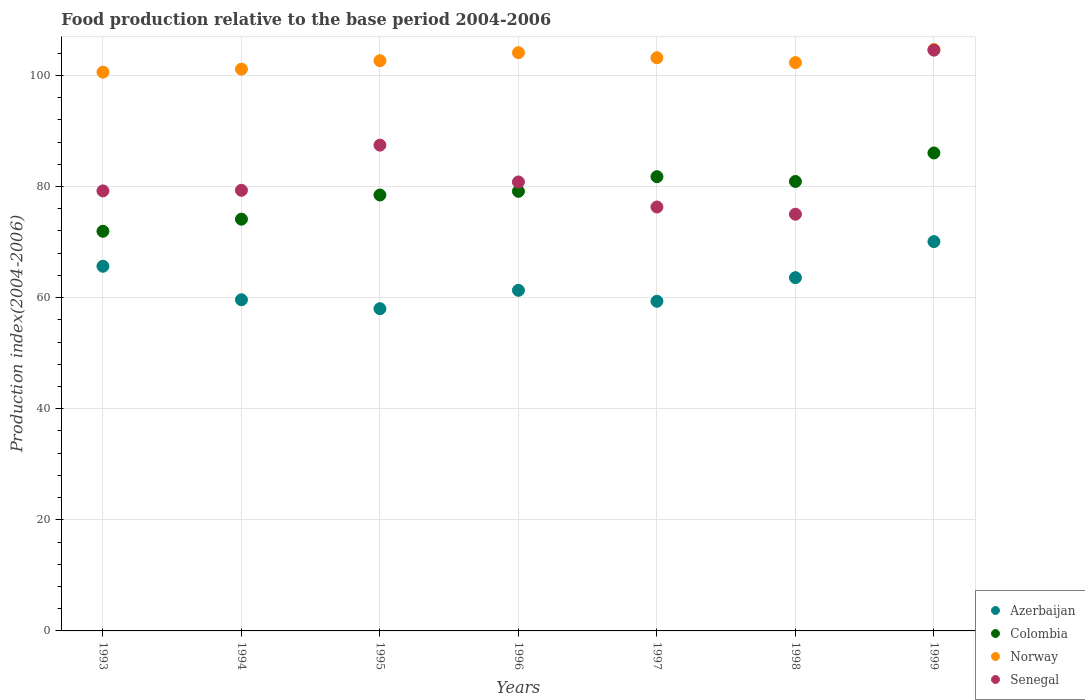How many different coloured dotlines are there?
Ensure brevity in your answer.  4. What is the food production index in Senegal in 1994?
Offer a terse response. 79.33. Across all years, what is the maximum food production index in Azerbaijan?
Your answer should be very brief. 70.09. Across all years, what is the minimum food production index in Colombia?
Your answer should be compact. 71.95. In which year was the food production index in Colombia maximum?
Ensure brevity in your answer.  1999. In which year was the food production index in Colombia minimum?
Offer a terse response. 1993. What is the total food production index in Senegal in the graph?
Give a very brief answer. 582.74. What is the difference between the food production index in Norway in 1996 and that in 1997?
Offer a terse response. 0.91. What is the difference between the food production index in Azerbaijan in 1994 and the food production index in Norway in 1999?
Offer a very short reply. -45.05. What is the average food production index in Senegal per year?
Keep it short and to the point. 83.25. In the year 1995, what is the difference between the food production index in Azerbaijan and food production index in Senegal?
Your answer should be compact. -29.45. What is the ratio of the food production index in Norway in 1993 to that in 1997?
Ensure brevity in your answer.  0.97. Is the food production index in Norway in 1994 less than that in 1999?
Your answer should be very brief. Yes. Is the difference between the food production index in Azerbaijan in 1995 and 1998 greater than the difference between the food production index in Senegal in 1995 and 1998?
Keep it short and to the point. No. What is the difference between the highest and the second highest food production index in Azerbaijan?
Your answer should be compact. 4.44. What is the difference between the highest and the lowest food production index in Senegal?
Your answer should be compact. 29.54. In how many years, is the food production index in Colombia greater than the average food production index in Colombia taken over all years?
Your response must be concise. 4. Is the sum of the food production index in Azerbaijan in 1996 and 1998 greater than the maximum food production index in Colombia across all years?
Provide a succinct answer. Yes. Is it the case that in every year, the sum of the food production index in Azerbaijan and food production index in Colombia  is greater than the food production index in Senegal?
Offer a very short reply. Yes. Is the food production index in Colombia strictly less than the food production index in Norway over the years?
Provide a short and direct response. Yes. How many dotlines are there?
Make the answer very short. 4. Are the values on the major ticks of Y-axis written in scientific E-notation?
Ensure brevity in your answer.  No. Does the graph contain any zero values?
Your answer should be compact. No. Does the graph contain grids?
Provide a succinct answer. Yes. Where does the legend appear in the graph?
Provide a short and direct response. Bottom right. How many legend labels are there?
Ensure brevity in your answer.  4. What is the title of the graph?
Ensure brevity in your answer.  Food production relative to the base period 2004-2006. Does "El Salvador" appear as one of the legend labels in the graph?
Provide a succinct answer. No. What is the label or title of the Y-axis?
Your response must be concise. Production index(2004-2006). What is the Production index(2004-2006) of Azerbaijan in 1993?
Make the answer very short. 65.65. What is the Production index(2004-2006) in Colombia in 1993?
Your answer should be very brief. 71.95. What is the Production index(2004-2006) of Norway in 1993?
Keep it short and to the point. 100.6. What is the Production index(2004-2006) of Senegal in 1993?
Offer a terse response. 79.22. What is the Production index(2004-2006) in Azerbaijan in 1994?
Your answer should be compact. 59.62. What is the Production index(2004-2006) of Colombia in 1994?
Keep it short and to the point. 74.13. What is the Production index(2004-2006) of Norway in 1994?
Your answer should be compact. 101.14. What is the Production index(2004-2006) of Senegal in 1994?
Make the answer very short. 79.33. What is the Production index(2004-2006) in Azerbaijan in 1995?
Your answer should be compact. 58.01. What is the Production index(2004-2006) of Colombia in 1995?
Provide a succinct answer. 78.48. What is the Production index(2004-2006) of Norway in 1995?
Offer a terse response. 102.66. What is the Production index(2004-2006) in Senegal in 1995?
Keep it short and to the point. 87.46. What is the Production index(2004-2006) of Azerbaijan in 1996?
Ensure brevity in your answer.  61.32. What is the Production index(2004-2006) in Colombia in 1996?
Ensure brevity in your answer.  79.14. What is the Production index(2004-2006) of Norway in 1996?
Offer a very short reply. 104.1. What is the Production index(2004-2006) in Senegal in 1996?
Offer a terse response. 80.83. What is the Production index(2004-2006) of Azerbaijan in 1997?
Your response must be concise. 59.35. What is the Production index(2004-2006) in Colombia in 1997?
Your answer should be compact. 81.78. What is the Production index(2004-2006) of Norway in 1997?
Make the answer very short. 103.19. What is the Production index(2004-2006) of Senegal in 1997?
Ensure brevity in your answer.  76.32. What is the Production index(2004-2006) of Azerbaijan in 1998?
Provide a short and direct response. 63.6. What is the Production index(2004-2006) of Colombia in 1998?
Provide a succinct answer. 80.92. What is the Production index(2004-2006) in Norway in 1998?
Your answer should be very brief. 102.32. What is the Production index(2004-2006) in Senegal in 1998?
Provide a short and direct response. 75.02. What is the Production index(2004-2006) in Azerbaijan in 1999?
Ensure brevity in your answer.  70.09. What is the Production index(2004-2006) of Colombia in 1999?
Offer a terse response. 86.05. What is the Production index(2004-2006) in Norway in 1999?
Give a very brief answer. 104.67. What is the Production index(2004-2006) of Senegal in 1999?
Your answer should be compact. 104.56. Across all years, what is the maximum Production index(2004-2006) in Azerbaijan?
Offer a very short reply. 70.09. Across all years, what is the maximum Production index(2004-2006) of Colombia?
Offer a very short reply. 86.05. Across all years, what is the maximum Production index(2004-2006) in Norway?
Offer a terse response. 104.67. Across all years, what is the maximum Production index(2004-2006) of Senegal?
Offer a very short reply. 104.56. Across all years, what is the minimum Production index(2004-2006) in Azerbaijan?
Make the answer very short. 58.01. Across all years, what is the minimum Production index(2004-2006) in Colombia?
Your answer should be very brief. 71.95. Across all years, what is the minimum Production index(2004-2006) of Norway?
Your response must be concise. 100.6. Across all years, what is the minimum Production index(2004-2006) in Senegal?
Offer a terse response. 75.02. What is the total Production index(2004-2006) of Azerbaijan in the graph?
Your answer should be very brief. 437.64. What is the total Production index(2004-2006) of Colombia in the graph?
Your answer should be compact. 552.45. What is the total Production index(2004-2006) of Norway in the graph?
Your answer should be compact. 718.68. What is the total Production index(2004-2006) of Senegal in the graph?
Make the answer very short. 582.74. What is the difference between the Production index(2004-2006) in Azerbaijan in 1993 and that in 1994?
Your answer should be compact. 6.03. What is the difference between the Production index(2004-2006) of Colombia in 1993 and that in 1994?
Keep it short and to the point. -2.18. What is the difference between the Production index(2004-2006) in Norway in 1993 and that in 1994?
Provide a succinct answer. -0.54. What is the difference between the Production index(2004-2006) in Senegal in 1993 and that in 1994?
Your answer should be very brief. -0.11. What is the difference between the Production index(2004-2006) of Azerbaijan in 1993 and that in 1995?
Offer a very short reply. 7.64. What is the difference between the Production index(2004-2006) in Colombia in 1993 and that in 1995?
Keep it short and to the point. -6.53. What is the difference between the Production index(2004-2006) of Norway in 1993 and that in 1995?
Your answer should be very brief. -2.06. What is the difference between the Production index(2004-2006) in Senegal in 1993 and that in 1995?
Offer a very short reply. -8.24. What is the difference between the Production index(2004-2006) of Azerbaijan in 1993 and that in 1996?
Provide a short and direct response. 4.33. What is the difference between the Production index(2004-2006) in Colombia in 1993 and that in 1996?
Your answer should be compact. -7.19. What is the difference between the Production index(2004-2006) of Senegal in 1993 and that in 1996?
Your answer should be very brief. -1.61. What is the difference between the Production index(2004-2006) in Azerbaijan in 1993 and that in 1997?
Your answer should be very brief. 6.3. What is the difference between the Production index(2004-2006) of Colombia in 1993 and that in 1997?
Your answer should be compact. -9.83. What is the difference between the Production index(2004-2006) in Norway in 1993 and that in 1997?
Offer a terse response. -2.59. What is the difference between the Production index(2004-2006) of Azerbaijan in 1993 and that in 1998?
Your answer should be compact. 2.05. What is the difference between the Production index(2004-2006) in Colombia in 1993 and that in 1998?
Provide a succinct answer. -8.97. What is the difference between the Production index(2004-2006) in Norway in 1993 and that in 1998?
Provide a short and direct response. -1.72. What is the difference between the Production index(2004-2006) of Senegal in 1993 and that in 1998?
Give a very brief answer. 4.2. What is the difference between the Production index(2004-2006) in Azerbaijan in 1993 and that in 1999?
Offer a very short reply. -4.44. What is the difference between the Production index(2004-2006) of Colombia in 1993 and that in 1999?
Provide a succinct answer. -14.1. What is the difference between the Production index(2004-2006) of Norway in 1993 and that in 1999?
Your answer should be very brief. -4.07. What is the difference between the Production index(2004-2006) of Senegal in 1993 and that in 1999?
Your response must be concise. -25.34. What is the difference between the Production index(2004-2006) in Azerbaijan in 1994 and that in 1995?
Provide a short and direct response. 1.61. What is the difference between the Production index(2004-2006) of Colombia in 1994 and that in 1995?
Give a very brief answer. -4.35. What is the difference between the Production index(2004-2006) of Norway in 1994 and that in 1995?
Your answer should be very brief. -1.52. What is the difference between the Production index(2004-2006) in Senegal in 1994 and that in 1995?
Your response must be concise. -8.13. What is the difference between the Production index(2004-2006) in Colombia in 1994 and that in 1996?
Your answer should be compact. -5.01. What is the difference between the Production index(2004-2006) of Norway in 1994 and that in 1996?
Provide a short and direct response. -2.96. What is the difference between the Production index(2004-2006) in Senegal in 1994 and that in 1996?
Provide a short and direct response. -1.5. What is the difference between the Production index(2004-2006) in Azerbaijan in 1994 and that in 1997?
Provide a succinct answer. 0.27. What is the difference between the Production index(2004-2006) in Colombia in 1994 and that in 1997?
Provide a short and direct response. -7.65. What is the difference between the Production index(2004-2006) in Norway in 1994 and that in 1997?
Offer a terse response. -2.05. What is the difference between the Production index(2004-2006) of Senegal in 1994 and that in 1997?
Ensure brevity in your answer.  3.01. What is the difference between the Production index(2004-2006) of Azerbaijan in 1994 and that in 1998?
Provide a short and direct response. -3.98. What is the difference between the Production index(2004-2006) of Colombia in 1994 and that in 1998?
Your answer should be very brief. -6.79. What is the difference between the Production index(2004-2006) in Norway in 1994 and that in 1998?
Keep it short and to the point. -1.18. What is the difference between the Production index(2004-2006) in Senegal in 1994 and that in 1998?
Provide a succinct answer. 4.31. What is the difference between the Production index(2004-2006) in Azerbaijan in 1994 and that in 1999?
Your answer should be compact. -10.47. What is the difference between the Production index(2004-2006) of Colombia in 1994 and that in 1999?
Make the answer very short. -11.92. What is the difference between the Production index(2004-2006) in Norway in 1994 and that in 1999?
Provide a short and direct response. -3.53. What is the difference between the Production index(2004-2006) of Senegal in 1994 and that in 1999?
Provide a short and direct response. -25.23. What is the difference between the Production index(2004-2006) in Azerbaijan in 1995 and that in 1996?
Your answer should be very brief. -3.31. What is the difference between the Production index(2004-2006) of Colombia in 1995 and that in 1996?
Give a very brief answer. -0.66. What is the difference between the Production index(2004-2006) in Norway in 1995 and that in 1996?
Make the answer very short. -1.44. What is the difference between the Production index(2004-2006) in Senegal in 1995 and that in 1996?
Your answer should be compact. 6.63. What is the difference between the Production index(2004-2006) of Azerbaijan in 1995 and that in 1997?
Provide a short and direct response. -1.34. What is the difference between the Production index(2004-2006) in Norway in 1995 and that in 1997?
Your answer should be compact. -0.53. What is the difference between the Production index(2004-2006) of Senegal in 1995 and that in 1997?
Your response must be concise. 11.14. What is the difference between the Production index(2004-2006) in Azerbaijan in 1995 and that in 1998?
Give a very brief answer. -5.59. What is the difference between the Production index(2004-2006) of Colombia in 1995 and that in 1998?
Provide a succinct answer. -2.44. What is the difference between the Production index(2004-2006) of Norway in 1995 and that in 1998?
Your answer should be very brief. 0.34. What is the difference between the Production index(2004-2006) in Senegal in 1995 and that in 1998?
Your response must be concise. 12.44. What is the difference between the Production index(2004-2006) of Azerbaijan in 1995 and that in 1999?
Make the answer very short. -12.08. What is the difference between the Production index(2004-2006) of Colombia in 1995 and that in 1999?
Give a very brief answer. -7.57. What is the difference between the Production index(2004-2006) of Norway in 1995 and that in 1999?
Offer a terse response. -2.01. What is the difference between the Production index(2004-2006) of Senegal in 1995 and that in 1999?
Provide a short and direct response. -17.1. What is the difference between the Production index(2004-2006) of Azerbaijan in 1996 and that in 1997?
Keep it short and to the point. 1.97. What is the difference between the Production index(2004-2006) in Colombia in 1996 and that in 1997?
Offer a very short reply. -2.64. What is the difference between the Production index(2004-2006) in Norway in 1996 and that in 1997?
Make the answer very short. 0.91. What is the difference between the Production index(2004-2006) in Senegal in 1996 and that in 1997?
Make the answer very short. 4.51. What is the difference between the Production index(2004-2006) in Azerbaijan in 1996 and that in 1998?
Offer a very short reply. -2.28. What is the difference between the Production index(2004-2006) in Colombia in 1996 and that in 1998?
Your answer should be very brief. -1.78. What is the difference between the Production index(2004-2006) in Norway in 1996 and that in 1998?
Your answer should be compact. 1.78. What is the difference between the Production index(2004-2006) in Senegal in 1996 and that in 1998?
Provide a short and direct response. 5.81. What is the difference between the Production index(2004-2006) of Azerbaijan in 1996 and that in 1999?
Offer a terse response. -8.77. What is the difference between the Production index(2004-2006) in Colombia in 1996 and that in 1999?
Give a very brief answer. -6.91. What is the difference between the Production index(2004-2006) of Norway in 1996 and that in 1999?
Provide a short and direct response. -0.57. What is the difference between the Production index(2004-2006) in Senegal in 1996 and that in 1999?
Offer a very short reply. -23.73. What is the difference between the Production index(2004-2006) of Azerbaijan in 1997 and that in 1998?
Provide a short and direct response. -4.25. What is the difference between the Production index(2004-2006) of Colombia in 1997 and that in 1998?
Provide a short and direct response. 0.86. What is the difference between the Production index(2004-2006) in Norway in 1997 and that in 1998?
Provide a succinct answer. 0.87. What is the difference between the Production index(2004-2006) in Azerbaijan in 1997 and that in 1999?
Offer a very short reply. -10.74. What is the difference between the Production index(2004-2006) in Colombia in 1997 and that in 1999?
Your answer should be compact. -4.27. What is the difference between the Production index(2004-2006) in Norway in 1997 and that in 1999?
Your answer should be very brief. -1.48. What is the difference between the Production index(2004-2006) of Senegal in 1997 and that in 1999?
Provide a short and direct response. -28.24. What is the difference between the Production index(2004-2006) of Azerbaijan in 1998 and that in 1999?
Your response must be concise. -6.49. What is the difference between the Production index(2004-2006) of Colombia in 1998 and that in 1999?
Provide a short and direct response. -5.13. What is the difference between the Production index(2004-2006) of Norway in 1998 and that in 1999?
Provide a short and direct response. -2.35. What is the difference between the Production index(2004-2006) of Senegal in 1998 and that in 1999?
Give a very brief answer. -29.54. What is the difference between the Production index(2004-2006) in Azerbaijan in 1993 and the Production index(2004-2006) in Colombia in 1994?
Your response must be concise. -8.48. What is the difference between the Production index(2004-2006) in Azerbaijan in 1993 and the Production index(2004-2006) in Norway in 1994?
Your response must be concise. -35.49. What is the difference between the Production index(2004-2006) of Azerbaijan in 1993 and the Production index(2004-2006) of Senegal in 1994?
Ensure brevity in your answer.  -13.68. What is the difference between the Production index(2004-2006) in Colombia in 1993 and the Production index(2004-2006) in Norway in 1994?
Provide a succinct answer. -29.19. What is the difference between the Production index(2004-2006) in Colombia in 1993 and the Production index(2004-2006) in Senegal in 1994?
Offer a terse response. -7.38. What is the difference between the Production index(2004-2006) of Norway in 1993 and the Production index(2004-2006) of Senegal in 1994?
Keep it short and to the point. 21.27. What is the difference between the Production index(2004-2006) in Azerbaijan in 1993 and the Production index(2004-2006) in Colombia in 1995?
Provide a short and direct response. -12.83. What is the difference between the Production index(2004-2006) of Azerbaijan in 1993 and the Production index(2004-2006) of Norway in 1995?
Ensure brevity in your answer.  -37.01. What is the difference between the Production index(2004-2006) of Azerbaijan in 1993 and the Production index(2004-2006) of Senegal in 1995?
Provide a short and direct response. -21.81. What is the difference between the Production index(2004-2006) of Colombia in 1993 and the Production index(2004-2006) of Norway in 1995?
Provide a succinct answer. -30.71. What is the difference between the Production index(2004-2006) of Colombia in 1993 and the Production index(2004-2006) of Senegal in 1995?
Keep it short and to the point. -15.51. What is the difference between the Production index(2004-2006) in Norway in 1993 and the Production index(2004-2006) in Senegal in 1995?
Provide a succinct answer. 13.14. What is the difference between the Production index(2004-2006) in Azerbaijan in 1993 and the Production index(2004-2006) in Colombia in 1996?
Make the answer very short. -13.49. What is the difference between the Production index(2004-2006) of Azerbaijan in 1993 and the Production index(2004-2006) of Norway in 1996?
Your answer should be very brief. -38.45. What is the difference between the Production index(2004-2006) in Azerbaijan in 1993 and the Production index(2004-2006) in Senegal in 1996?
Provide a succinct answer. -15.18. What is the difference between the Production index(2004-2006) of Colombia in 1993 and the Production index(2004-2006) of Norway in 1996?
Offer a terse response. -32.15. What is the difference between the Production index(2004-2006) in Colombia in 1993 and the Production index(2004-2006) in Senegal in 1996?
Ensure brevity in your answer.  -8.88. What is the difference between the Production index(2004-2006) of Norway in 1993 and the Production index(2004-2006) of Senegal in 1996?
Offer a very short reply. 19.77. What is the difference between the Production index(2004-2006) in Azerbaijan in 1993 and the Production index(2004-2006) in Colombia in 1997?
Your answer should be very brief. -16.13. What is the difference between the Production index(2004-2006) of Azerbaijan in 1993 and the Production index(2004-2006) of Norway in 1997?
Ensure brevity in your answer.  -37.54. What is the difference between the Production index(2004-2006) of Azerbaijan in 1993 and the Production index(2004-2006) of Senegal in 1997?
Ensure brevity in your answer.  -10.67. What is the difference between the Production index(2004-2006) of Colombia in 1993 and the Production index(2004-2006) of Norway in 1997?
Provide a short and direct response. -31.24. What is the difference between the Production index(2004-2006) of Colombia in 1993 and the Production index(2004-2006) of Senegal in 1997?
Your answer should be very brief. -4.37. What is the difference between the Production index(2004-2006) in Norway in 1993 and the Production index(2004-2006) in Senegal in 1997?
Provide a short and direct response. 24.28. What is the difference between the Production index(2004-2006) in Azerbaijan in 1993 and the Production index(2004-2006) in Colombia in 1998?
Offer a very short reply. -15.27. What is the difference between the Production index(2004-2006) in Azerbaijan in 1993 and the Production index(2004-2006) in Norway in 1998?
Give a very brief answer. -36.67. What is the difference between the Production index(2004-2006) in Azerbaijan in 1993 and the Production index(2004-2006) in Senegal in 1998?
Keep it short and to the point. -9.37. What is the difference between the Production index(2004-2006) of Colombia in 1993 and the Production index(2004-2006) of Norway in 1998?
Provide a succinct answer. -30.37. What is the difference between the Production index(2004-2006) in Colombia in 1993 and the Production index(2004-2006) in Senegal in 1998?
Make the answer very short. -3.07. What is the difference between the Production index(2004-2006) in Norway in 1993 and the Production index(2004-2006) in Senegal in 1998?
Your answer should be compact. 25.58. What is the difference between the Production index(2004-2006) of Azerbaijan in 1993 and the Production index(2004-2006) of Colombia in 1999?
Your response must be concise. -20.4. What is the difference between the Production index(2004-2006) of Azerbaijan in 1993 and the Production index(2004-2006) of Norway in 1999?
Your answer should be compact. -39.02. What is the difference between the Production index(2004-2006) in Azerbaijan in 1993 and the Production index(2004-2006) in Senegal in 1999?
Ensure brevity in your answer.  -38.91. What is the difference between the Production index(2004-2006) of Colombia in 1993 and the Production index(2004-2006) of Norway in 1999?
Make the answer very short. -32.72. What is the difference between the Production index(2004-2006) in Colombia in 1993 and the Production index(2004-2006) in Senegal in 1999?
Your response must be concise. -32.61. What is the difference between the Production index(2004-2006) in Norway in 1993 and the Production index(2004-2006) in Senegal in 1999?
Ensure brevity in your answer.  -3.96. What is the difference between the Production index(2004-2006) in Azerbaijan in 1994 and the Production index(2004-2006) in Colombia in 1995?
Your answer should be compact. -18.86. What is the difference between the Production index(2004-2006) of Azerbaijan in 1994 and the Production index(2004-2006) of Norway in 1995?
Your answer should be very brief. -43.04. What is the difference between the Production index(2004-2006) in Azerbaijan in 1994 and the Production index(2004-2006) in Senegal in 1995?
Provide a succinct answer. -27.84. What is the difference between the Production index(2004-2006) in Colombia in 1994 and the Production index(2004-2006) in Norway in 1995?
Offer a terse response. -28.53. What is the difference between the Production index(2004-2006) of Colombia in 1994 and the Production index(2004-2006) of Senegal in 1995?
Give a very brief answer. -13.33. What is the difference between the Production index(2004-2006) in Norway in 1994 and the Production index(2004-2006) in Senegal in 1995?
Give a very brief answer. 13.68. What is the difference between the Production index(2004-2006) in Azerbaijan in 1994 and the Production index(2004-2006) in Colombia in 1996?
Provide a short and direct response. -19.52. What is the difference between the Production index(2004-2006) of Azerbaijan in 1994 and the Production index(2004-2006) of Norway in 1996?
Make the answer very short. -44.48. What is the difference between the Production index(2004-2006) of Azerbaijan in 1994 and the Production index(2004-2006) of Senegal in 1996?
Provide a short and direct response. -21.21. What is the difference between the Production index(2004-2006) of Colombia in 1994 and the Production index(2004-2006) of Norway in 1996?
Ensure brevity in your answer.  -29.97. What is the difference between the Production index(2004-2006) of Norway in 1994 and the Production index(2004-2006) of Senegal in 1996?
Make the answer very short. 20.31. What is the difference between the Production index(2004-2006) of Azerbaijan in 1994 and the Production index(2004-2006) of Colombia in 1997?
Provide a short and direct response. -22.16. What is the difference between the Production index(2004-2006) in Azerbaijan in 1994 and the Production index(2004-2006) in Norway in 1997?
Give a very brief answer. -43.57. What is the difference between the Production index(2004-2006) of Azerbaijan in 1994 and the Production index(2004-2006) of Senegal in 1997?
Make the answer very short. -16.7. What is the difference between the Production index(2004-2006) in Colombia in 1994 and the Production index(2004-2006) in Norway in 1997?
Provide a short and direct response. -29.06. What is the difference between the Production index(2004-2006) in Colombia in 1994 and the Production index(2004-2006) in Senegal in 1997?
Your answer should be very brief. -2.19. What is the difference between the Production index(2004-2006) in Norway in 1994 and the Production index(2004-2006) in Senegal in 1997?
Provide a succinct answer. 24.82. What is the difference between the Production index(2004-2006) in Azerbaijan in 1994 and the Production index(2004-2006) in Colombia in 1998?
Provide a short and direct response. -21.3. What is the difference between the Production index(2004-2006) of Azerbaijan in 1994 and the Production index(2004-2006) of Norway in 1998?
Keep it short and to the point. -42.7. What is the difference between the Production index(2004-2006) of Azerbaijan in 1994 and the Production index(2004-2006) of Senegal in 1998?
Your answer should be compact. -15.4. What is the difference between the Production index(2004-2006) of Colombia in 1994 and the Production index(2004-2006) of Norway in 1998?
Your response must be concise. -28.19. What is the difference between the Production index(2004-2006) of Colombia in 1994 and the Production index(2004-2006) of Senegal in 1998?
Give a very brief answer. -0.89. What is the difference between the Production index(2004-2006) of Norway in 1994 and the Production index(2004-2006) of Senegal in 1998?
Your answer should be very brief. 26.12. What is the difference between the Production index(2004-2006) in Azerbaijan in 1994 and the Production index(2004-2006) in Colombia in 1999?
Provide a short and direct response. -26.43. What is the difference between the Production index(2004-2006) in Azerbaijan in 1994 and the Production index(2004-2006) in Norway in 1999?
Offer a very short reply. -45.05. What is the difference between the Production index(2004-2006) of Azerbaijan in 1994 and the Production index(2004-2006) of Senegal in 1999?
Offer a very short reply. -44.94. What is the difference between the Production index(2004-2006) of Colombia in 1994 and the Production index(2004-2006) of Norway in 1999?
Your response must be concise. -30.54. What is the difference between the Production index(2004-2006) of Colombia in 1994 and the Production index(2004-2006) of Senegal in 1999?
Offer a very short reply. -30.43. What is the difference between the Production index(2004-2006) of Norway in 1994 and the Production index(2004-2006) of Senegal in 1999?
Keep it short and to the point. -3.42. What is the difference between the Production index(2004-2006) in Azerbaijan in 1995 and the Production index(2004-2006) in Colombia in 1996?
Ensure brevity in your answer.  -21.13. What is the difference between the Production index(2004-2006) in Azerbaijan in 1995 and the Production index(2004-2006) in Norway in 1996?
Offer a terse response. -46.09. What is the difference between the Production index(2004-2006) in Azerbaijan in 1995 and the Production index(2004-2006) in Senegal in 1996?
Make the answer very short. -22.82. What is the difference between the Production index(2004-2006) of Colombia in 1995 and the Production index(2004-2006) of Norway in 1996?
Offer a terse response. -25.62. What is the difference between the Production index(2004-2006) in Colombia in 1995 and the Production index(2004-2006) in Senegal in 1996?
Provide a succinct answer. -2.35. What is the difference between the Production index(2004-2006) in Norway in 1995 and the Production index(2004-2006) in Senegal in 1996?
Offer a very short reply. 21.83. What is the difference between the Production index(2004-2006) in Azerbaijan in 1995 and the Production index(2004-2006) in Colombia in 1997?
Offer a terse response. -23.77. What is the difference between the Production index(2004-2006) of Azerbaijan in 1995 and the Production index(2004-2006) of Norway in 1997?
Your answer should be very brief. -45.18. What is the difference between the Production index(2004-2006) of Azerbaijan in 1995 and the Production index(2004-2006) of Senegal in 1997?
Offer a terse response. -18.31. What is the difference between the Production index(2004-2006) of Colombia in 1995 and the Production index(2004-2006) of Norway in 1997?
Ensure brevity in your answer.  -24.71. What is the difference between the Production index(2004-2006) in Colombia in 1995 and the Production index(2004-2006) in Senegal in 1997?
Give a very brief answer. 2.16. What is the difference between the Production index(2004-2006) of Norway in 1995 and the Production index(2004-2006) of Senegal in 1997?
Your answer should be compact. 26.34. What is the difference between the Production index(2004-2006) of Azerbaijan in 1995 and the Production index(2004-2006) of Colombia in 1998?
Give a very brief answer. -22.91. What is the difference between the Production index(2004-2006) of Azerbaijan in 1995 and the Production index(2004-2006) of Norway in 1998?
Your response must be concise. -44.31. What is the difference between the Production index(2004-2006) in Azerbaijan in 1995 and the Production index(2004-2006) in Senegal in 1998?
Make the answer very short. -17.01. What is the difference between the Production index(2004-2006) in Colombia in 1995 and the Production index(2004-2006) in Norway in 1998?
Ensure brevity in your answer.  -23.84. What is the difference between the Production index(2004-2006) in Colombia in 1995 and the Production index(2004-2006) in Senegal in 1998?
Offer a very short reply. 3.46. What is the difference between the Production index(2004-2006) of Norway in 1995 and the Production index(2004-2006) of Senegal in 1998?
Offer a terse response. 27.64. What is the difference between the Production index(2004-2006) of Azerbaijan in 1995 and the Production index(2004-2006) of Colombia in 1999?
Keep it short and to the point. -28.04. What is the difference between the Production index(2004-2006) of Azerbaijan in 1995 and the Production index(2004-2006) of Norway in 1999?
Your answer should be compact. -46.66. What is the difference between the Production index(2004-2006) of Azerbaijan in 1995 and the Production index(2004-2006) of Senegal in 1999?
Offer a very short reply. -46.55. What is the difference between the Production index(2004-2006) in Colombia in 1995 and the Production index(2004-2006) in Norway in 1999?
Offer a very short reply. -26.19. What is the difference between the Production index(2004-2006) in Colombia in 1995 and the Production index(2004-2006) in Senegal in 1999?
Make the answer very short. -26.08. What is the difference between the Production index(2004-2006) in Norway in 1995 and the Production index(2004-2006) in Senegal in 1999?
Your answer should be very brief. -1.9. What is the difference between the Production index(2004-2006) of Azerbaijan in 1996 and the Production index(2004-2006) of Colombia in 1997?
Give a very brief answer. -20.46. What is the difference between the Production index(2004-2006) in Azerbaijan in 1996 and the Production index(2004-2006) in Norway in 1997?
Ensure brevity in your answer.  -41.87. What is the difference between the Production index(2004-2006) of Azerbaijan in 1996 and the Production index(2004-2006) of Senegal in 1997?
Offer a very short reply. -15. What is the difference between the Production index(2004-2006) in Colombia in 1996 and the Production index(2004-2006) in Norway in 1997?
Offer a terse response. -24.05. What is the difference between the Production index(2004-2006) in Colombia in 1996 and the Production index(2004-2006) in Senegal in 1997?
Make the answer very short. 2.82. What is the difference between the Production index(2004-2006) of Norway in 1996 and the Production index(2004-2006) of Senegal in 1997?
Keep it short and to the point. 27.78. What is the difference between the Production index(2004-2006) of Azerbaijan in 1996 and the Production index(2004-2006) of Colombia in 1998?
Your response must be concise. -19.6. What is the difference between the Production index(2004-2006) of Azerbaijan in 1996 and the Production index(2004-2006) of Norway in 1998?
Provide a succinct answer. -41. What is the difference between the Production index(2004-2006) of Azerbaijan in 1996 and the Production index(2004-2006) of Senegal in 1998?
Your response must be concise. -13.7. What is the difference between the Production index(2004-2006) of Colombia in 1996 and the Production index(2004-2006) of Norway in 1998?
Offer a terse response. -23.18. What is the difference between the Production index(2004-2006) of Colombia in 1996 and the Production index(2004-2006) of Senegal in 1998?
Provide a short and direct response. 4.12. What is the difference between the Production index(2004-2006) of Norway in 1996 and the Production index(2004-2006) of Senegal in 1998?
Ensure brevity in your answer.  29.08. What is the difference between the Production index(2004-2006) of Azerbaijan in 1996 and the Production index(2004-2006) of Colombia in 1999?
Provide a short and direct response. -24.73. What is the difference between the Production index(2004-2006) of Azerbaijan in 1996 and the Production index(2004-2006) of Norway in 1999?
Offer a very short reply. -43.35. What is the difference between the Production index(2004-2006) in Azerbaijan in 1996 and the Production index(2004-2006) in Senegal in 1999?
Your response must be concise. -43.24. What is the difference between the Production index(2004-2006) in Colombia in 1996 and the Production index(2004-2006) in Norway in 1999?
Offer a very short reply. -25.53. What is the difference between the Production index(2004-2006) of Colombia in 1996 and the Production index(2004-2006) of Senegal in 1999?
Provide a succinct answer. -25.42. What is the difference between the Production index(2004-2006) of Norway in 1996 and the Production index(2004-2006) of Senegal in 1999?
Ensure brevity in your answer.  -0.46. What is the difference between the Production index(2004-2006) of Azerbaijan in 1997 and the Production index(2004-2006) of Colombia in 1998?
Offer a terse response. -21.57. What is the difference between the Production index(2004-2006) of Azerbaijan in 1997 and the Production index(2004-2006) of Norway in 1998?
Provide a succinct answer. -42.97. What is the difference between the Production index(2004-2006) in Azerbaijan in 1997 and the Production index(2004-2006) in Senegal in 1998?
Ensure brevity in your answer.  -15.67. What is the difference between the Production index(2004-2006) in Colombia in 1997 and the Production index(2004-2006) in Norway in 1998?
Offer a terse response. -20.54. What is the difference between the Production index(2004-2006) in Colombia in 1997 and the Production index(2004-2006) in Senegal in 1998?
Your response must be concise. 6.76. What is the difference between the Production index(2004-2006) of Norway in 1997 and the Production index(2004-2006) of Senegal in 1998?
Offer a terse response. 28.17. What is the difference between the Production index(2004-2006) of Azerbaijan in 1997 and the Production index(2004-2006) of Colombia in 1999?
Ensure brevity in your answer.  -26.7. What is the difference between the Production index(2004-2006) in Azerbaijan in 1997 and the Production index(2004-2006) in Norway in 1999?
Make the answer very short. -45.32. What is the difference between the Production index(2004-2006) of Azerbaijan in 1997 and the Production index(2004-2006) of Senegal in 1999?
Offer a very short reply. -45.21. What is the difference between the Production index(2004-2006) of Colombia in 1997 and the Production index(2004-2006) of Norway in 1999?
Offer a terse response. -22.89. What is the difference between the Production index(2004-2006) of Colombia in 1997 and the Production index(2004-2006) of Senegal in 1999?
Provide a succinct answer. -22.78. What is the difference between the Production index(2004-2006) in Norway in 1997 and the Production index(2004-2006) in Senegal in 1999?
Give a very brief answer. -1.37. What is the difference between the Production index(2004-2006) of Azerbaijan in 1998 and the Production index(2004-2006) of Colombia in 1999?
Your answer should be compact. -22.45. What is the difference between the Production index(2004-2006) of Azerbaijan in 1998 and the Production index(2004-2006) of Norway in 1999?
Your answer should be very brief. -41.07. What is the difference between the Production index(2004-2006) of Azerbaijan in 1998 and the Production index(2004-2006) of Senegal in 1999?
Ensure brevity in your answer.  -40.96. What is the difference between the Production index(2004-2006) in Colombia in 1998 and the Production index(2004-2006) in Norway in 1999?
Offer a very short reply. -23.75. What is the difference between the Production index(2004-2006) of Colombia in 1998 and the Production index(2004-2006) of Senegal in 1999?
Provide a short and direct response. -23.64. What is the difference between the Production index(2004-2006) in Norway in 1998 and the Production index(2004-2006) in Senegal in 1999?
Your answer should be very brief. -2.24. What is the average Production index(2004-2006) in Azerbaijan per year?
Offer a terse response. 62.52. What is the average Production index(2004-2006) in Colombia per year?
Your response must be concise. 78.92. What is the average Production index(2004-2006) of Norway per year?
Offer a very short reply. 102.67. What is the average Production index(2004-2006) in Senegal per year?
Give a very brief answer. 83.25. In the year 1993, what is the difference between the Production index(2004-2006) of Azerbaijan and Production index(2004-2006) of Colombia?
Your answer should be compact. -6.3. In the year 1993, what is the difference between the Production index(2004-2006) of Azerbaijan and Production index(2004-2006) of Norway?
Provide a short and direct response. -34.95. In the year 1993, what is the difference between the Production index(2004-2006) in Azerbaijan and Production index(2004-2006) in Senegal?
Ensure brevity in your answer.  -13.57. In the year 1993, what is the difference between the Production index(2004-2006) of Colombia and Production index(2004-2006) of Norway?
Ensure brevity in your answer.  -28.65. In the year 1993, what is the difference between the Production index(2004-2006) of Colombia and Production index(2004-2006) of Senegal?
Give a very brief answer. -7.27. In the year 1993, what is the difference between the Production index(2004-2006) in Norway and Production index(2004-2006) in Senegal?
Keep it short and to the point. 21.38. In the year 1994, what is the difference between the Production index(2004-2006) in Azerbaijan and Production index(2004-2006) in Colombia?
Your response must be concise. -14.51. In the year 1994, what is the difference between the Production index(2004-2006) in Azerbaijan and Production index(2004-2006) in Norway?
Offer a very short reply. -41.52. In the year 1994, what is the difference between the Production index(2004-2006) in Azerbaijan and Production index(2004-2006) in Senegal?
Your response must be concise. -19.71. In the year 1994, what is the difference between the Production index(2004-2006) in Colombia and Production index(2004-2006) in Norway?
Keep it short and to the point. -27.01. In the year 1994, what is the difference between the Production index(2004-2006) in Norway and Production index(2004-2006) in Senegal?
Give a very brief answer. 21.81. In the year 1995, what is the difference between the Production index(2004-2006) in Azerbaijan and Production index(2004-2006) in Colombia?
Ensure brevity in your answer.  -20.47. In the year 1995, what is the difference between the Production index(2004-2006) in Azerbaijan and Production index(2004-2006) in Norway?
Ensure brevity in your answer.  -44.65. In the year 1995, what is the difference between the Production index(2004-2006) in Azerbaijan and Production index(2004-2006) in Senegal?
Make the answer very short. -29.45. In the year 1995, what is the difference between the Production index(2004-2006) of Colombia and Production index(2004-2006) of Norway?
Your response must be concise. -24.18. In the year 1995, what is the difference between the Production index(2004-2006) in Colombia and Production index(2004-2006) in Senegal?
Your answer should be compact. -8.98. In the year 1995, what is the difference between the Production index(2004-2006) of Norway and Production index(2004-2006) of Senegal?
Your answer should be very brief. 15.2. In the year 1996, what is the difference between the Production index(2004-2006) in Azerbaijan and Production index(2004-2006) in Colombia?
Give a very brief answer. -17.82. In the year 1996, what is the difference between the Production index(2004-2006) in Azerbaijan and Production index(2004-2006) in Norway?
Provide a short and direct response. -42.78. In the year 1996, what is the difference between the Production index(2004-2006) in Azerbaijan and Production index(2004-2006) in Senegal?
Your answer should be compact. -19.51. In the year 1996, what is the difference between the Production index(2004-2006) in Colombia and Production index(2004-2006) in Norway?
Offer a terse response. -24.96. In the year 1996, what is the difference between the Production index(2004-2006) in Colombia and Production index(2004-2006) in Senegal?
Your answer should be very brief. -1.69. In the year 1996, what is the difference between the Production index(2004-2006) in Norway and Production index(2004-2006) in Senegal?
Provide a succinct answer. 23.27. In the year 1997, what is the difference between the Production index(2004-2006) in Azerbaijan and Production index(2004-2006) in Colombia?
Offer a very short reply. -22.43. In the year 1997, what is the difference between the Production index(2004-2006) in Azerbaijan and Production index(2004-2006) in Norway?
Your answer should be very brief. -43.84. In the year 1997, what is the difference between the Production index(2004-2006) of Azerbaijan and Production index(2004-2006) of Senegal?
Make the answer very short. -16.97. In the year 1997, what is the difference between the Production index(2004-2006) in Colombia and Production index(2004-2006) in Norway?
Offer a terse response. -21.41. In the year 1997, what is the difference between the Production index(2004-2006) of Colombia and Production index(2004-2006) of Senegal?
Keep it short and to the point. 5.46. In the year 1997, what is the difference between the Production index(2004-2006) in Norway and Production index(2004-2006) in Senegal?
Ensure brevity in your answer.  26.87. In the year 1998, what is the difference between the Production index(2004-2006) of Azerbaijan and Production index(2004-2006) of Colombia?
Ensure brevity in your answer.  -17.32. In the year 1998, what is the difference between the Production index(2004-2006) in Azerbaijan and Production index(2004-2006) in Norway?
Keep it short and to the point. -38.72. In the year 1998, what is the difference between the Production index(2004-2006) in Azerbaijan and Production index(2004-2006) in Senegal?
Give a very brief answer. -11.42. In the year 1998, what is the difference between the Production index(2004-2006) in Colombia and Production index(2004-2006) in Norway?
Make the answer very short. -21.4. In the year 1998, what is the difference between the Production index(2004-2006) of Colombia and Production index(2004-2006) of Senegal?
Provide a short and direct response. 5.9. In the year 1998, what is the difference between the Production index(2004-2006) in Norway and Production index(2004-2006) in Senegal?
Provide a succinct answer. 27.3. In the year 1999, what is the difference between the Production index(2004-2006) in Azerbaijan and Production index(2004-2006) in Colombia?
Ensure brevity in your answer.  -15.96. In the year 1999, what is the difference between the Production index(2004-2006) in Azerbaijan and Production index(2004-2006) in Norway?
Offer a terse response. -34.58. In the year 1999, what is the difference between the Production index(2004-2006) of Azerbaijan and Production index(2004-2006) of Senegal?
Provide a succinct answer. -34.47. In the year 1999, what is the difference between the Production index(2004-2006) in Colombia and Production index(2004-2006) in Norway?
Offer a very short reply. -18.62. In the year 1999, what is the difference between the Production index(2004-2006) in Colombia and Production index(2004-2006) in Senegal?
Provide a succinct answer. -18.51. In the year 1999, what is the difference between the Production index(2004-2006) of Norway and Production index(2004-2006) of Senegal?
Provide a succinct answer. 0.11. What is the ratio of the Production index(2004-2006) in Azerbaijan in 1993 to that in 1994?
Your answer should be compact. 1.1. What is the ratio of the Production index(2004-2006) in Colombia in 1993 to that in 1994?
Give a very brief answer. 0.97. What is the ratio of the Production index(2004-2006) of Norway in 1993 to that in 1994?
Provide a succinct answer. 0.99. What is the ratio of the Production index(2004-2006) in Senegal in 1993 to that in 1994?
Make the answer very short. 1. What is the ratio of the Production index(2004-2006) of Azerbaijan in 1993 to that in 1995?
Your answer should be compact. 1.13. What is the ratio of the Production index(2004-2006) in Colombia in 1993 to that in 1995?
Give a very brief answer. 0.92. What is the ratio of the Production index(2004-2006) in Norway in 1993 to that in 1995?
Give a very brief answer. 0.98. What is the ratio of the Production index(2004-2006) of Senegal in 1993 to that in 1995?
Offer a very short reply. 0.91. What is the ratio of the Production index(2004-2006) in Azerbaijan in 1993 to that in 1996?
Ensure brevity in your answer.  1.07. What is the ratio of the Production index(2004-2006) of Norway in 1993 to that in 1996?
Offer a terse response. 0.97. What is the ratio of the Production index(2004-2006) of Senegal in 1993 to that in 1996?
Provide a short and direct response. 0.98. What is the ratio of the Production index(2004-2006) in Azerbaijan in 1993 to that in 1997?
Your response must be concise. 1.11. What is the ratio of the Production index(2004-2006) of Colombia in 1993 to that in 1997?
Your answer should be compact. 0.88. What is the ratio of the Production index(2004-2006) in Norway in 1993 to that in 1997?
Keep it short and to the point. 0.97. What is the ratio of the Production index(2004-2006) of Senegal in 1993 to that in 1997?
Provide a succinct answer. 1.04. What is the ratio of the Production index(2004-2006) in Azerbaijan in 1993 to that in 1998?
Keep it short and to the point. 1.03. What is the ratio of the Production index(2004-2006) in Colombia in 1993 to that in 1998?
Your answer should be very brief. 0.89. What is the ratio of the Production index(2004-2006) in Norway in 1993 to that in 1998?
Provide a short and direct response. 0.98. What is the ratio of the Production index(2004-2006) in Senegal in 1993 to that in 1998?
Ensure brevity in your answer.  1.06. What is the ratio of the Production index(2004-2006) of Azerbaijan in 1993 to that in 1999?
Your response must be concise. 0.94. What is the ratio of the Production index(2004-2006) of Colombia in 1993 to that in 1999?
Provide a succinct answer. 0.84. What is the ratio of the Production index(2004-2006) of Norway in 1993 to that in 1999?
Make the answer very short. 0.96. What is the ratio of the Production index(2004-2006) of Senegal in 1993 to that in 1999?
Give a very brief answer. 0.76. What is the ratio of the Production index(2004-2006) in Azerbaijan in 1994 to that in 1995?
Your answer should be compact. 1.03. What is the ratio of the Production index(2004-2006) of Colombia in 1994 to that in 1995?
Make the answer very short. 0.94. What is the ratio of the Production index(2004-2006) of Norway in 1994 to that in 1995?
Your response must be concise. 0.99. What is the ratio of the Production index(2004-2006) of Senegal in 1994 to that in 1995?
Give a very brief answer. 0.91. What is the ratio of the Production index(2004-2006) in Azerbaijan in 1994 to that in 1996?
Keep it short and to the point. 0.97. What is the ratio of the Production index(2004-2006) of Colombia in 1994 to that in 1996?
Provide a short and direct response. 0.94. What is the ratio of the Production index(2004-2006) of Norway in 1994 to that in 1996?
Your answer should be compact. 0.97. What is the ratio of the Production index(2004-2006) of Senegal in 1994 to that in 1996?
Provide a short and direct response. 0.98. What is the ratio of the Production index(2004-2006) of Colombia in 1994 to that in 1997?
Provide a succinct answer. 0.91. What is the ratio of the Production index(2004-2006) in Norway in 1994 to that in 1997?
Provide a short and direct response. 0.98. What is the ratio of the Production index(2004-2006) of Senegal in 1994 to that in 1997?
Give a very brief answer. 1.04. What is the ratio of the Production index(2004-2006) of Azerbaijan in 1994 to that in 1998?
Give a very brief answer. 0.94. What is the ratio of the Production index(2004-2006) in Colombia in 1994 to that in 1998?
Offer a very short reply. 0.92. What is the ratio of the Production index(2004-2006) of Norway in 1994 to that in 1998?
Provide a succinct answer. 0.99. What is the ratio of the Production index(2004-2006) in Senegal in 1994 to that in 1998?
Your response must be concise. 1.06. What is the ratio of the Production index(2004-2006) in Azerbaijan in 1994 to that in 1999?
Provide a short and direct response. 0.85. What is the ratio of the Production index(2004-2006) of Colombia in 1994 to that in 1999?
Your answer should be compact. 0.86. What is the ratio of the Production index(2004-2006) in Norway in 1994 to that in 1999?
Your answer should be very brief. 0.97. What is the ratio of the Production index(2004-2006) of Senegal in 1994 to that in 1999?
Offer a very short reply. 0.76. What is the ratio of the Production index(2004-2006) of Azerbaijan in 1995 to that in 1996?
Provide a short and direct response. 0.95. What is the ratio of the Production index(2004-2006) in Norway in 1995 to that in 1996?
Your answer should be compact. 0.99. What is the ratio of the Production index(2004-2006) of Senegal in 1995 to that in 1996?
Keep it short and to the point. 1.08. What is the ratio of the Production index(2004-2006) of Azerbaijan in 1995 to that in 1997?
Provide a succinct answer. 0.98. What is the ratio of the Production index(2004-2006) of Colombia in 1995 to that in 1997?
Your answer should be compact. 0.96. What is the ratio of the Production index(2004-2006) in Senegal in 1995 to that in 1997?
Provide a short and direct response. 1.15. What is the ratio of the Production index(2004-2006) in Azerbaijan in 1995 to that in 1998?
Ensure brevity in your answer.  0.91. What is the ratio of the Production index(2004-2006) in Colombia in 1995 to that in 1998?
Keep it short and to the point. 0.97. What is the ratio of the Production index(2004-2006) of Norway in 1995 to that in 1998?
Your response must be concise. 1. What is the ratio of the Production index(2004-2006) of Senegal in 1995 to that in 1998?
Your answer should be very brief. 1.17. What is the ratio of the Production index(2004-2006) in Azerbaijan in 1995 to that in 1999?
Your response must be concise. 0.83. What is the ratio of the Production index(2004-2006) of Colombia in 1995 to that in 1999?
Ensure brevity in your answer.  0.91. What is the ratio of the Production index(2004-2006) of Norway in 1995 to that in 1999?
Your answer should be very brief. 0.98. What is the ratio of the Production index(2004-2006) of Senegal in 1995 to that in 1999?
Provide a short and direct response. 0.84. What is the ratio of the Production index(2004-2006) of Azerbaijan in 1996 to that in 1997?
Offer a terse response. 1.03. What is the ratio of the Production index(2004-2006) in Norway in 1996 to that in 1997?
Make the answer very short. 1.01. What is the ratio of the Production index(2004-2006) in Senegal in 1996 to that in 1997?
Keep it short and to the point. 1.06. What is the ratio of the Production index(2004-2006) in Azerbaijan in 1996 to that in 1998?
Your answer should be compact. 0.96. What is the ratio of the Production index(2004-2006) in Colombia in 1996 to that in 1998?
Your response must be concise. 0.98. What is the ratio of the Production index(2004-2006) in Norway in 1996 to that in 1998?
Make the answer very short. 1.02. What is the ratio of the Production index(2004-2006) of Senegal in 1996 to that in 1998?
Offer a very short reply. 1.08. What is the ratio of the Production index(2004-2006) in Azerbaijan in 1996 to that in 1999?
Provide a succinct answer. 0.87. What is the ratio of the Production index(2004-2006) of Colombia in 1996 to that in 1999?
Your answer should be compact. 0.92. What is the ratio of the Production index(2004-2006) in Senegal in 1996 to that in 1999?
Offer a very short reply. 0.77. What is the ratio of the Production index(2004-2006) of Azerbaijan in 1997 to that in 1998?
Make the answer very short. 0.93. What is the ratio of the Production index(2004-2006) of Colombia in 1997 to that in 1998?
Make the answer very short. 1.01. What is the ratio of the Production index(2004-2006) of Norway in 1997 to that in 1998?
Provide a short and direct response. 1.01. What is the ratio of the Production index(2004-2006) in Senegal in 1997 to that in 1998?
Provide a succinct answer. 1.02. What is the ratio of the Production index(2004-2006) of Azerbaijan in 1997 to that in 1999?
Make the answer very short. 0.85. What is the ratio of the Production index(2004-2006) in Colombia in 1997 to that in 1999?
Provide a succinct answer. 0.95. What is the ratio of the Production index(2004-2006) of Norway in 1997 to that in 1999?
Provide a succinct answer. 0.99. What is the ratio of the Production index(2004-2006) of Senegal in 1997 to that in 1999?
Ensure brevity in your answer.  0.73. What is the ratio of the Production index(2004-2006) of Azerbaijan in 1998 to that in 1999?
Give a very brief answer. 0.91. What is the ratio of the Production index(2004-2006) of Colombia in 1998 to that in 1999?
Make the answer very short. 0.94. What is the ratio of the Production index(2004-2006) in Norway in 1998 to that in 1999?
Provide a succinct answer. 0.98. What is the ratio of the Production index(2004-2006) in Senegal in 1998 to that in 1999?
Your response must be concise. 0.72. What is the difference between the highest and the second highest Production index(2004-2006) in Azerbaijan?
Provide a short and direct response. 4.44. What is the difference between the highest and the second highest Production index(2004-2006) in Colombia?
Provide a short and direct response. 4.27. What is the difference between the highest and the second highest Production index(2004-2006) of Norway?
Give a very brief answer. 0.57. What is the difference between the highest and the lowest Production index(2004-2006) of Azerbaijan?
Give a very brief answer. 12.08. What is the difference between the highest and the lowest Production index(2004-2006) in Norway?
Your answer should be very brief. 4.07. What is the difference between the highest and the lowest Production index(2004-2006) of Senegal?
Provide a short and direct response. 29.54. 